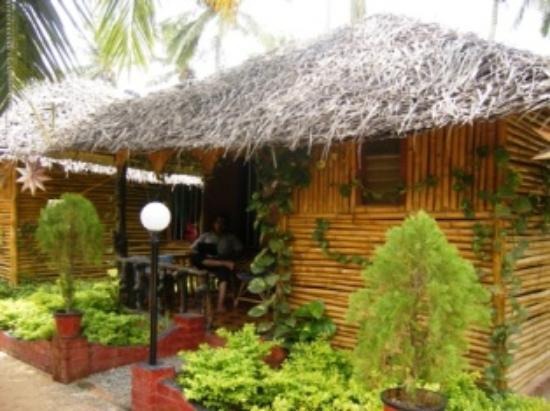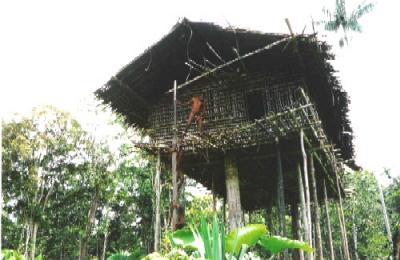The first image is the image on the left, the second image is the image on the right. For the images displayed, is the sentence "The right image contains a tree house." factually correct? Answer yes or no. Yes. The first image is the image on the left, the second image is the image on the right. Examine the images to the left and right. Is the description "A house with a thatched roof is up on stilts." accurate? Answer yes or no. Yes. 